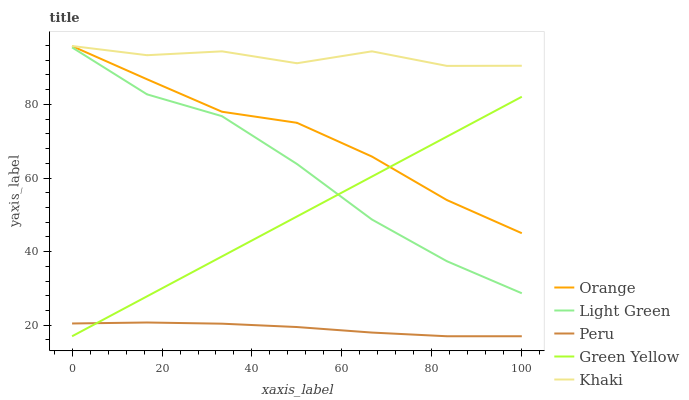Does Peru have the minimum area under the curve?
Answer yes or no. Yes. Does Khaki have the maximum area under the curve?
Answer yes or no. Yes. Does Green Yellow have the minimum area under the curve?
Answer yes or no. No. Does Green Yellow have the maximum area under the curve?
Answer yes or no. No. Is Green Yellow the smoothest?
Answer yes or no. Yes. Is Khaki the roughest?
Answer yes or no. Yes. Is Khaki the smoothest?
Answer yes or no. No. Is Green Yellow the roughest?
Answer yes or no. No. Does Green Yellow have the lowest value?
Answer yes or no. Yes. Does Khaki have the lowest value?
Answer yes or no. No. Does Khaki have the highest value?
Answer yes or no. Yes. Does Green Yellow have the highest value?
Answer yes or no. No. Is Orange less than Khaki?
Answer yes or no. Yes. Is Khaki greater than Light Green?
Answer yes or no. Yes. Does Orange intersect Green Yellow?
Answer yes or no. Yes. Is Orange less than Green Yellow?
Answer yes or no. No. Is Orange greater than Green Yellow?
Answer yes or no. No. Does Orange intersect Khaki?
Answer yes or no. No. 